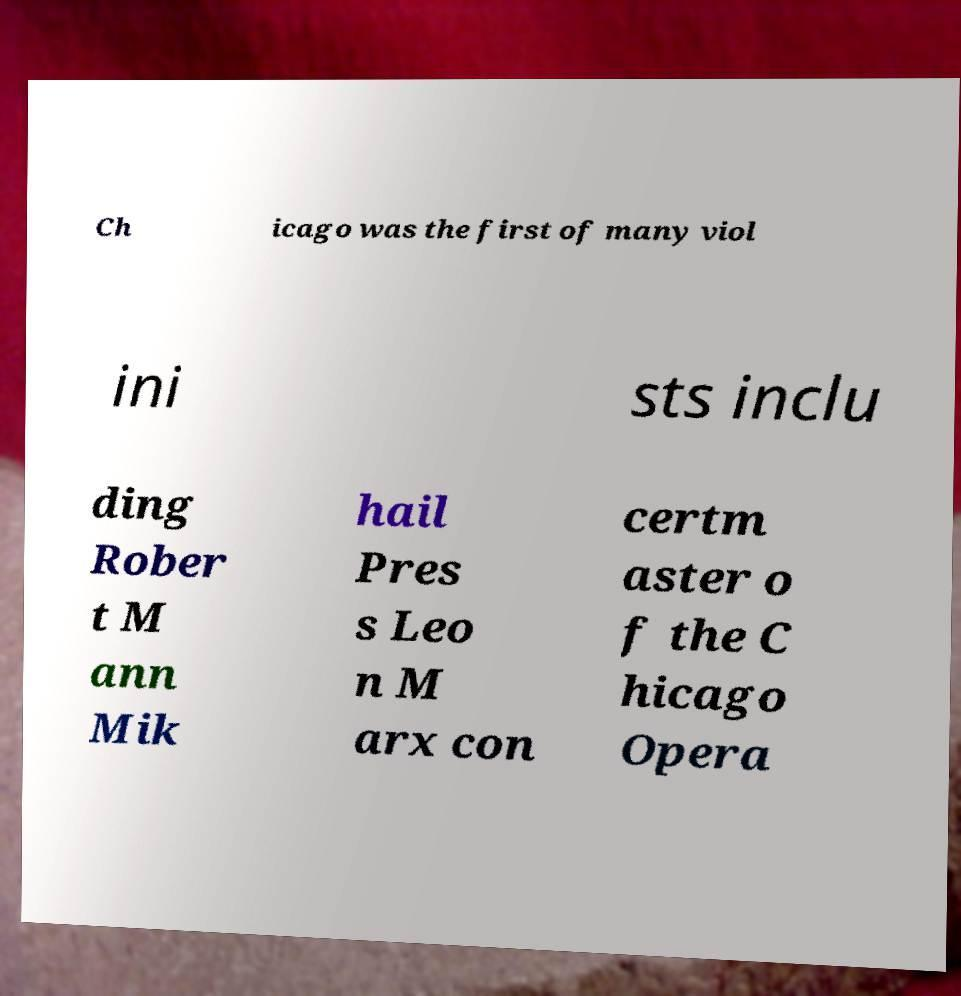Can you read and provide the text displayed in the image?This photo seems to have some interesting text. Can you extract and type it out for me? Ch icago was the first of many viol ini sts inclu ding Rober t M ann Mik hail Pres s Leo n M arx con certm aster o f the C hicago Opera 